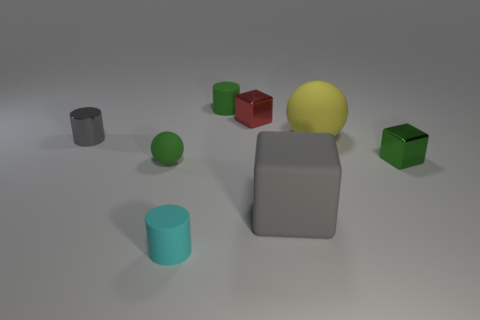Is the number of small matte balls that are in front of the small cyan thing less than the number of tiny red shiny cubes in front of the big yellow rubber sphere?
Give a very brief answer. No. How big is the ball that is on the left side of the cyan matte cylinder that is left of the metal thing that is on the right side of the tiny red cube?
Make the answer very short. Small. There is a gray object that is to the left of the cyan object; does it have the same size as the yellow object?
Give a very brief answer. No. How many other objects are the same material as the big block?
Make the answer very short. 4. Are there more small red objects than big cyan matte cylinders?
Provide a short and direct response. Yes. The small green object that is behind the red metal cube that is in front of the tiny green object behind the shiny cylinder is made of what material?
Make the answer very short. Rubber. Is the color of the big matte sphere the same as the small sphere?
Give a very brief answer. No. Is there a large ball that has the same color as the large block?
Give a very brief answer. No. There is a yellow object that is the same size as the gray block; what is its shape?
Ensure brevity in your answer.  Sphere. Is the number of tiny purple blocks less than the number of gray matte cubes?
Make the answer very short. Yes. 